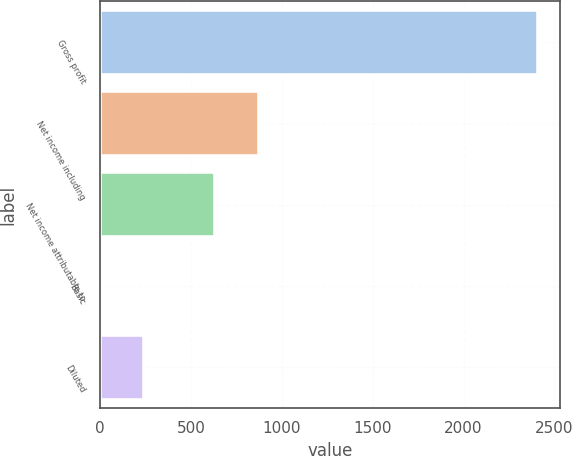Convert chart. <chart><loc_0><loc_0><loc_500><loc_500><bar_chart><fcel>Gross profit<fcel>Net income including<fcel>Net income attributable to<fcel>Basic<fcel>Diluted<nl><fcel>2408<fcel>874.73<fcel>634<fcel>0.72<fcel>241.45<nl></chart> 